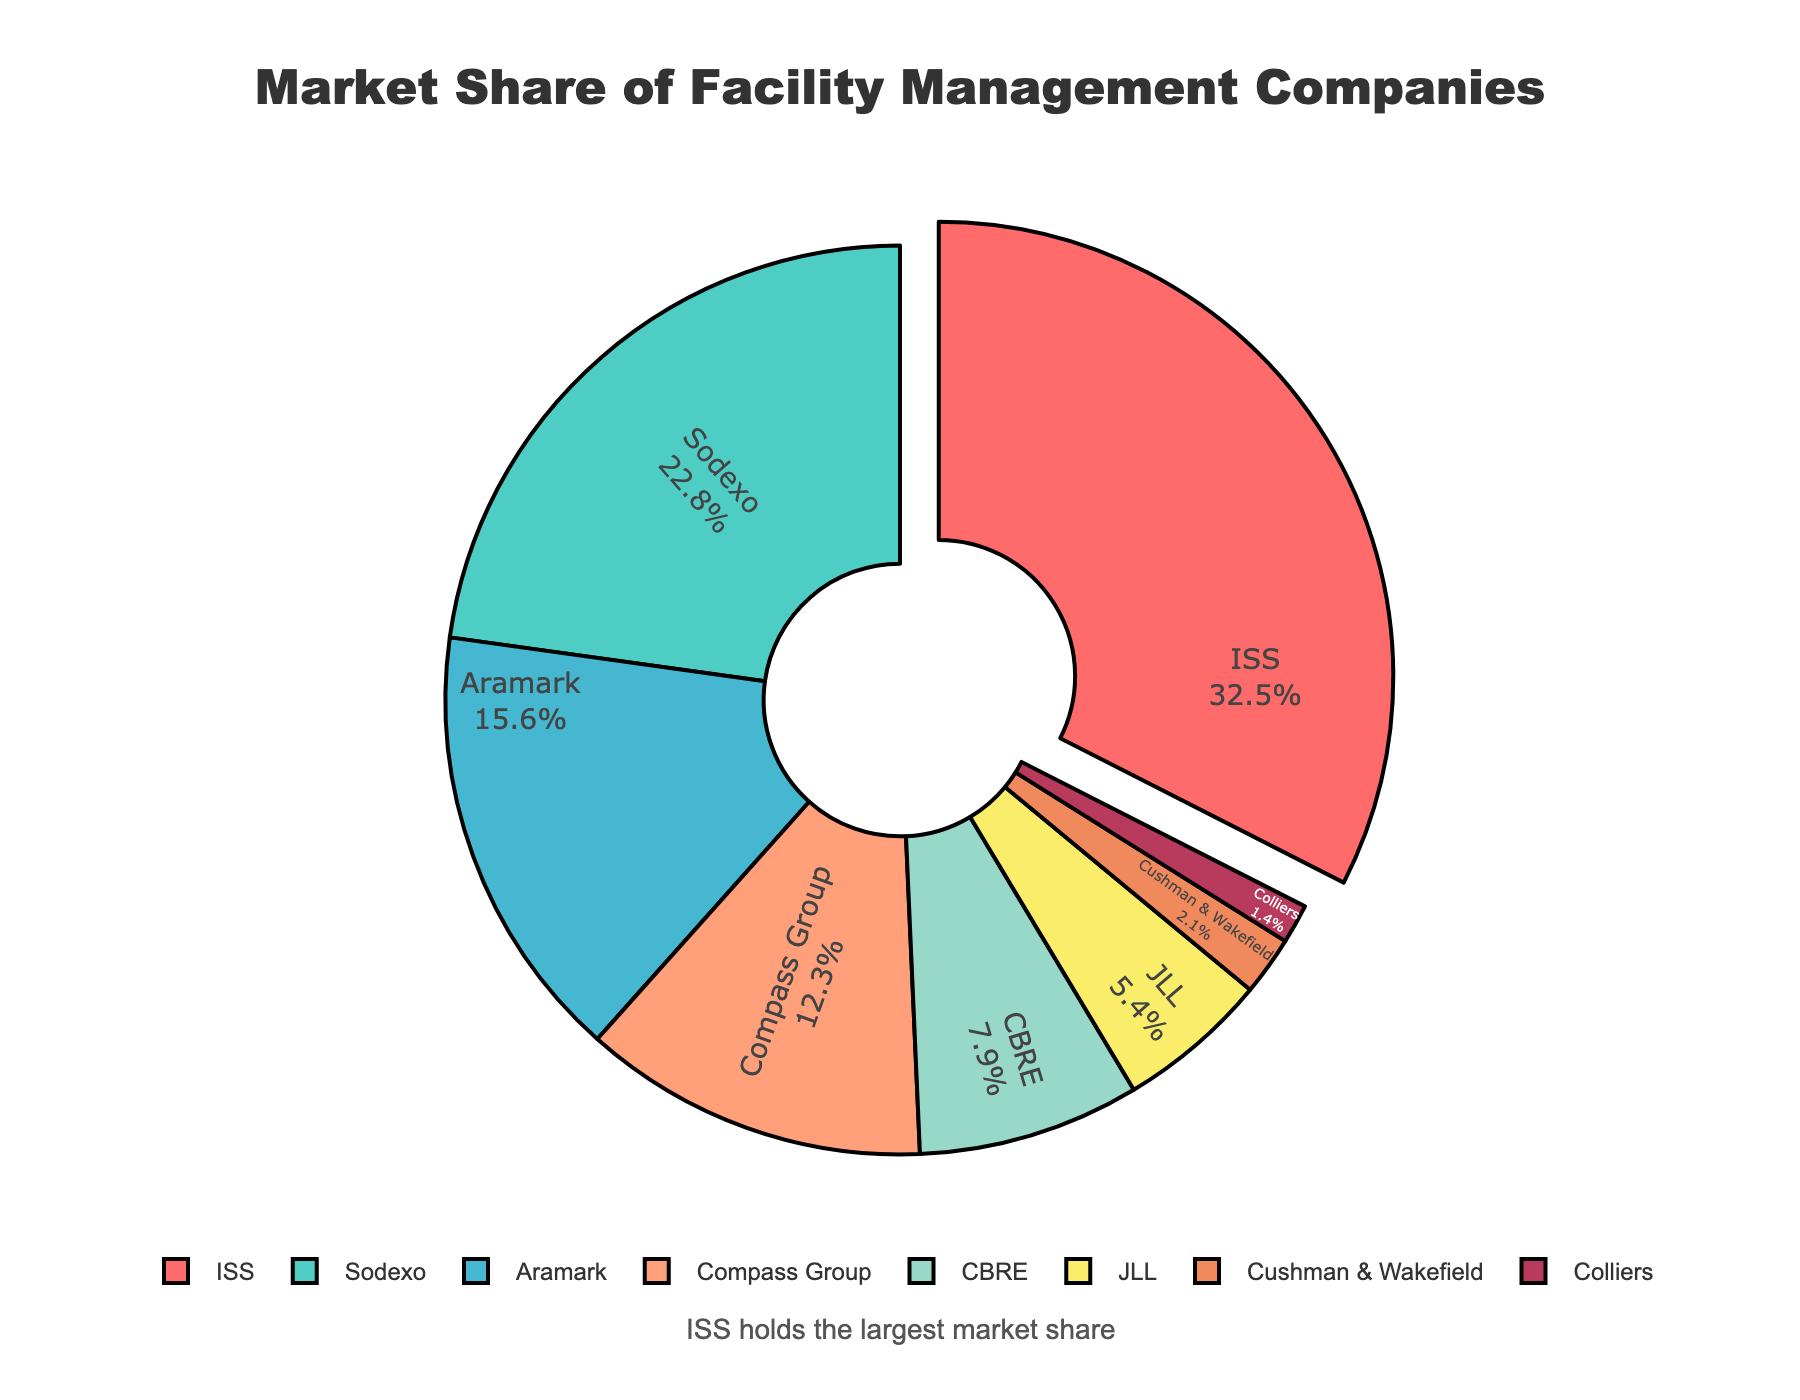What's the total market share of the three companies with the smallest shares? First, identify the three companies with the smallest shares: Cushman & Wakefield (2.1%), Colliers (1.4%), and JLL (5.4%). Sum their market shares: 2.1 + 1.4 + 5.4 = 8.9.
Answer: 8.9% Which company has the second-largest market share, and what is it? Observing the pie chart, the company with the second-largest segment is Sodexo, representing 22.8% of the market share.
Answer: Sodexo with 22.8% How much more market share does ISS have compared to Compass Group? ISS's market share is 32.5%, while Compass Group's market share is 12.3%. The difference is 32.5 - 12.3 = 20.2.
Answer: 20.2% What is the combined market share of CBRE and JLL? CBRE's market share is 7.9%, and JLL's market share is 5.4%. Their combined market share is 7.9 + 5.4 = 13.3.
Answer: 13.3% What percentage of the market share is held by companies other than ISS? ISS holds 32.5% of the market share. The total market share is 100%, so the market share held by other companies is 100 - 32.5 = 67.5.
Answer: 67.5% Which companies have market shares greater than 15%, and what are their respective shares? The companies with market shares greater than 15% are ISS with 32.5%, Sodexo with 22.8%, and Aramark with 15.6%.
Answer: ISS: 32.5%, Sodexo: 22.8%, Aramark: 15.6% What's the visual indication that ISS holds the largest market share? The pie chart visually indicates that ISS holds the largest market share by pulling its segment out slightly from the rest of the pie chart. Additionally, a text annotation underneath the chart states "ISS holds the largest market share."
Answer: Pulled-out segment and annotation 